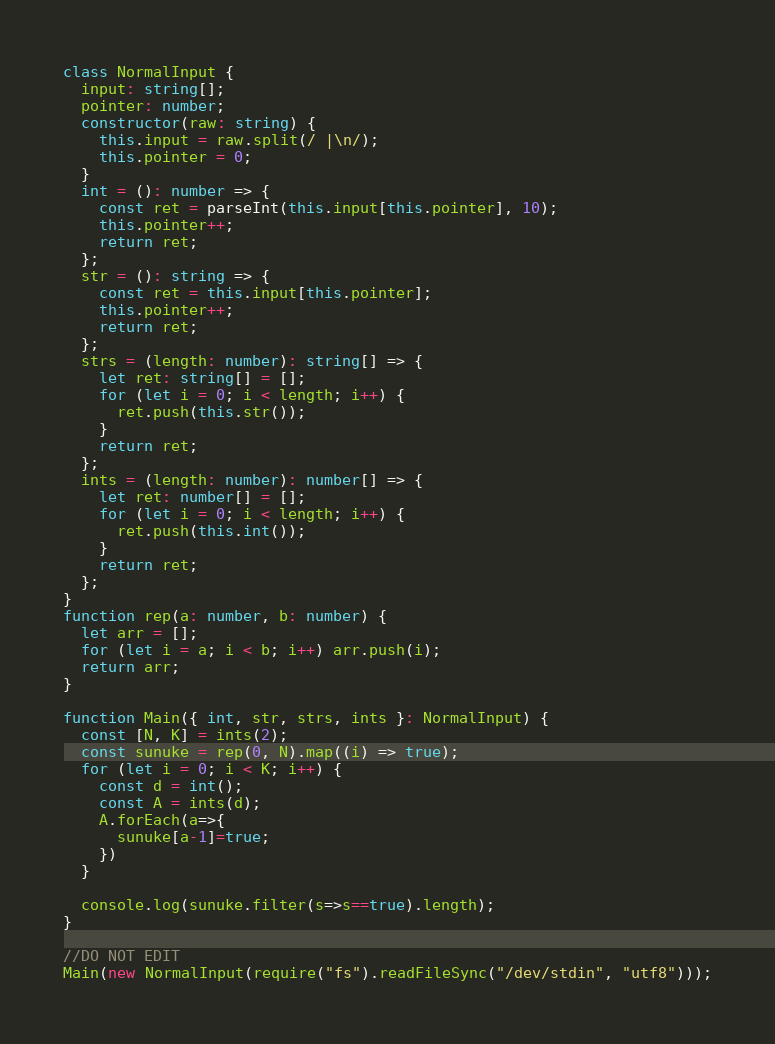Convert code to text. <code><loc_0><loc_0><loc_500><loc_500><_TypeScript_>class NormalInput {
  input: string[];
  pointer: number;
  constructor(raw: string) {
    this.input = raw.split(/ |\n/);
    this.pointer = 0;
  }
  int = (): number => {
    const ret = parseInt(this.input[this.pointer], 10);
    this.pointer++;
    return ret;
  };
  str = (): string => {
    const ret = this.input[this.pointer];
    this.pointer++;
    return ret;
  };
  strs = (length: number): string[] => {
    let ret: string[] = [];
    for (let i = 0; i < length; i++) {
      ret.push(this.str());
    }
    return ret;
  };
  ints = (length: number): number[] => {
    let ret: number[] = [];
    for (let i = 0; i < length; i++) {
      ret.push(this.int());
    }
    return ret;
  };
}
function rep(a: number, b: number) {
  let arr = [];
  for (let i = a; i < b; i++) arr.push(i);
  return arr;
}

function Main({ int, str, strs, ints }: NormalInput) {
  const [N, K] = ints(2);
  const sunuke = rep(0, N).map((i) => true);
  for (let i = 0; i < K; i++) {
    const d = int();
    const A = ints(d);
    A.forEach(a=>{
      sunuke[a-1]=true;
    })
  }

  console.log(sunuke.filter(s=>s==true).length);
}

//DO NOT EDIT
Main(new NormalInput(require("fs").readFileSync("/dev/stdin", "utf8")));
</code> 